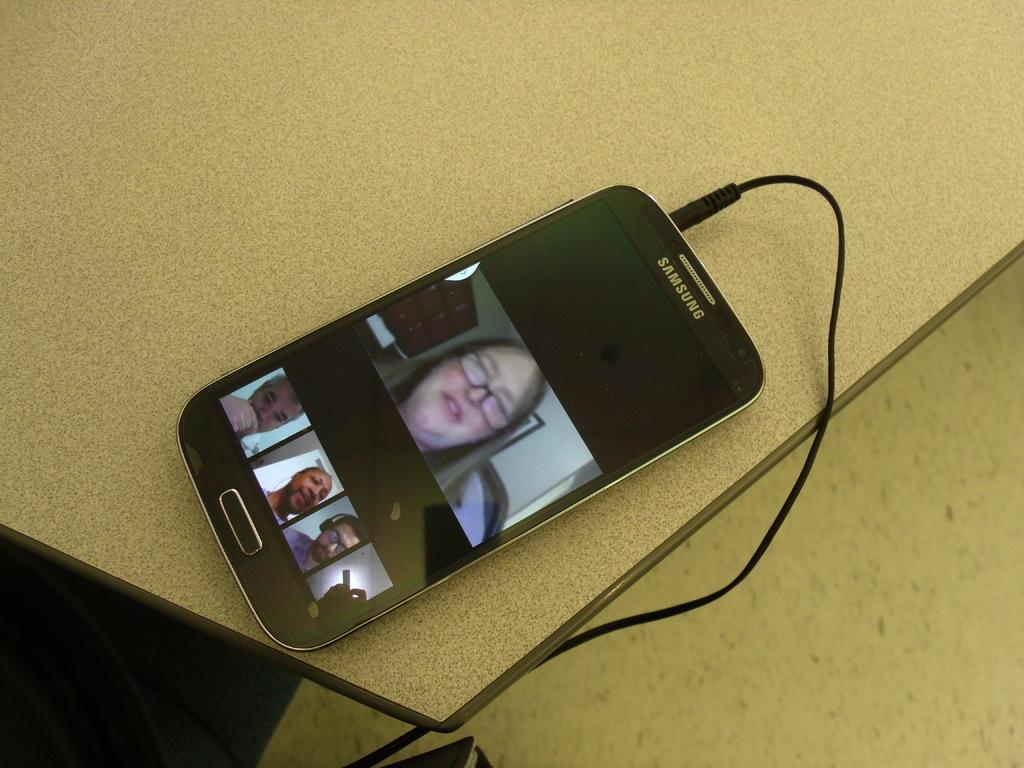<image>
Present a compact description of the photo's key features. A Samsung phone that is plugged in and sitting on a white table. 